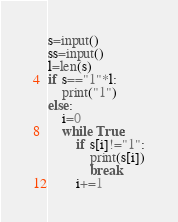Convert code to text. <code><loc_0><loc_0><loc_500><loc_500><_Python_>s=input()
ss=input()
l=len(s)
if s=="1"*l:
    print("1")
else:
    i=0
    while True:
        if s[i]!="1":
            print(s[i])
            break
        i+=1
</code> 